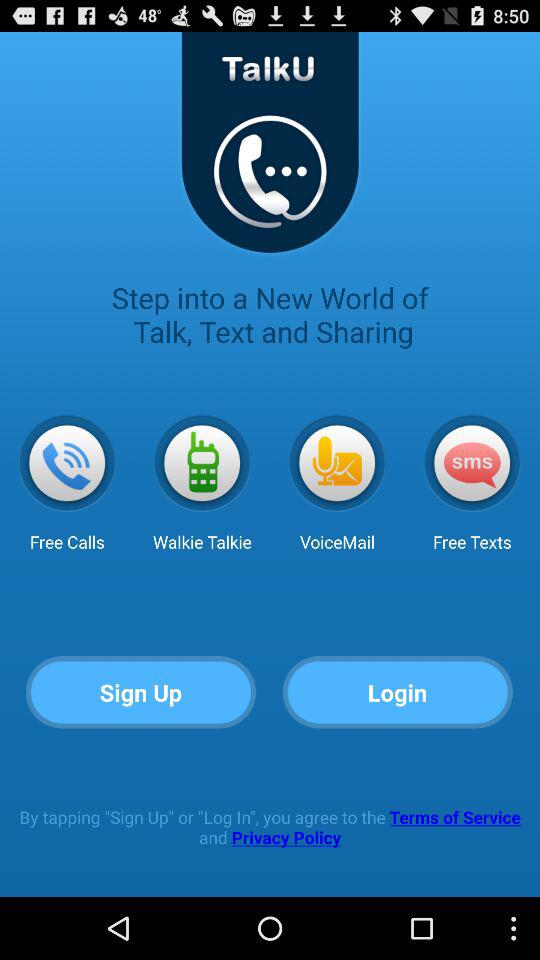Is "Sign Up" selected?
When the provided information is insufficient, respond with <no answer>. <no answer> 